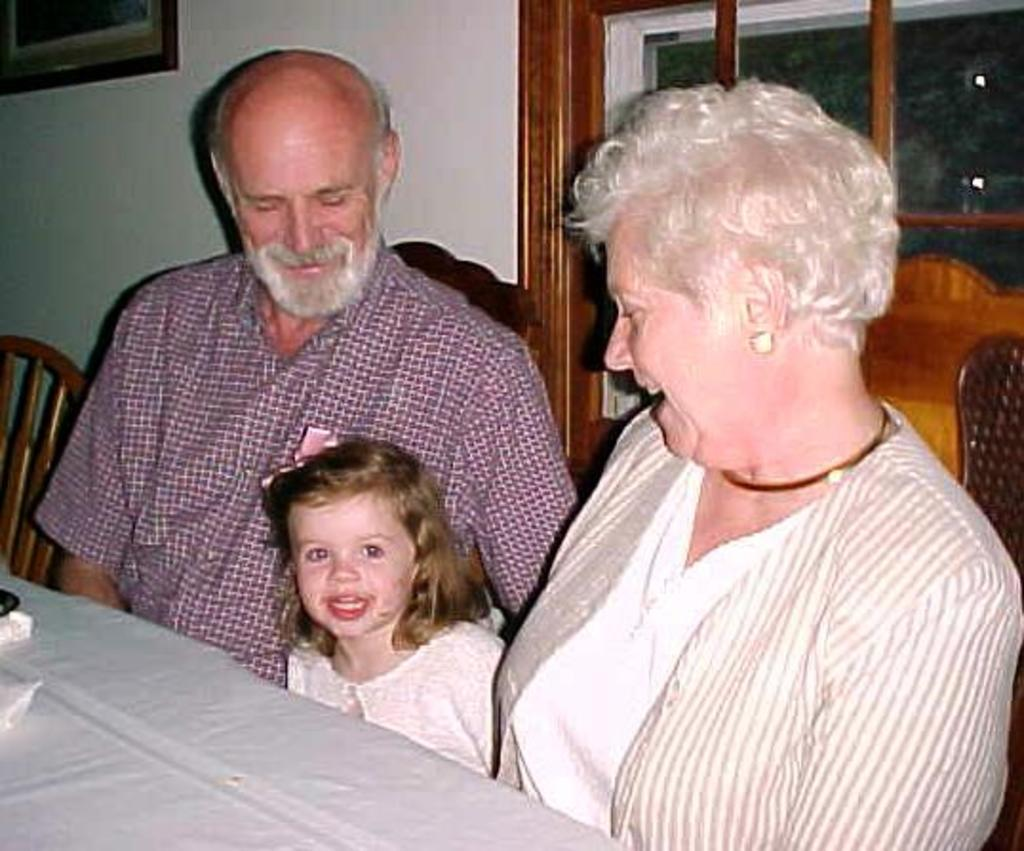What are the people in the image doing? The people in the image are sitting on chairs. What is in front of the chairs? There is a table in front of the chairs. What can be seen in the background of the image? There is a wall in the background of the image. What is on the wall? There is a window and a photo frame on the wall. What type of cabbage is being used as a tablecloth in the image? There is no cabbage present in the image, and it is not being used as a tablecloth. 